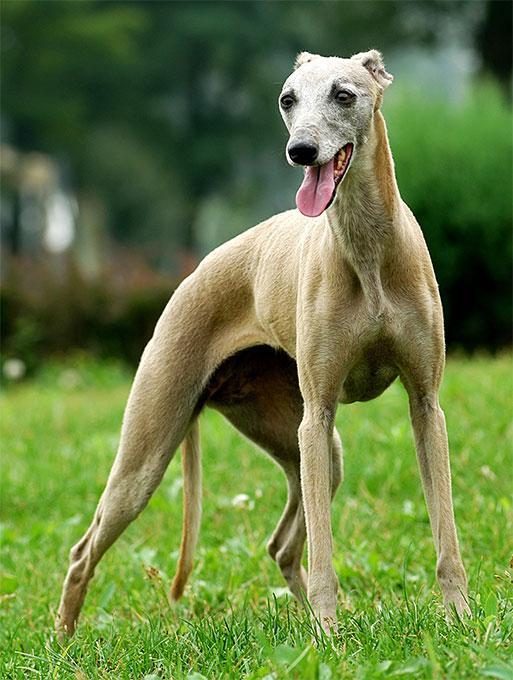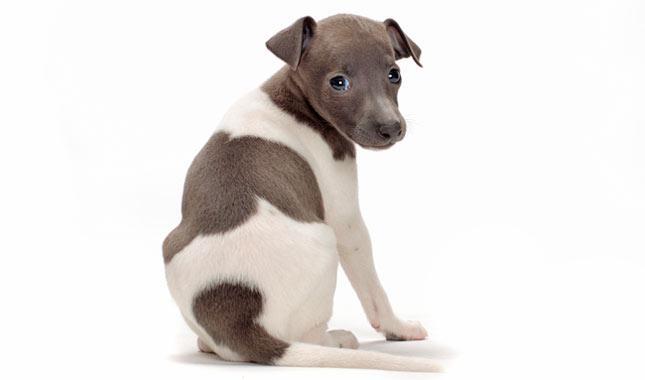The first image is the image on the left, the second image is the image on the right. Given the left and right images, does the statement "No less than four dog legs are visible" hold true? Answer yes or no. Yes. The first image is the image on the left, the second image is the image on the right. Analyze the images presented: Is the assertion "Left image shows a dog with a bright white neck marking." valid? Answer yes or no. No. 